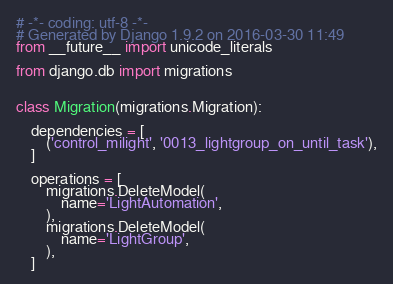Convert code to text. <code><loc_0><loc_0><loc_500><loc_500><_Python_># -*- coding: utf-8 -*-
# Generated by Django 1.9.2 on 2016-03-30 11:49
from __future__ import unicode_literals

from django.db import migrations


class Migration(migrations.Migration):

    dependencies = [
        ('control_milight', '0013_lightgroup_on_until_task'),
    ]

    operations = [
        migrations.DeleteModel(
            name='LightAutomation',
        ),
        migrations.DeleteModel(
            name='LightGroup',
        ),
    ]
</code> 